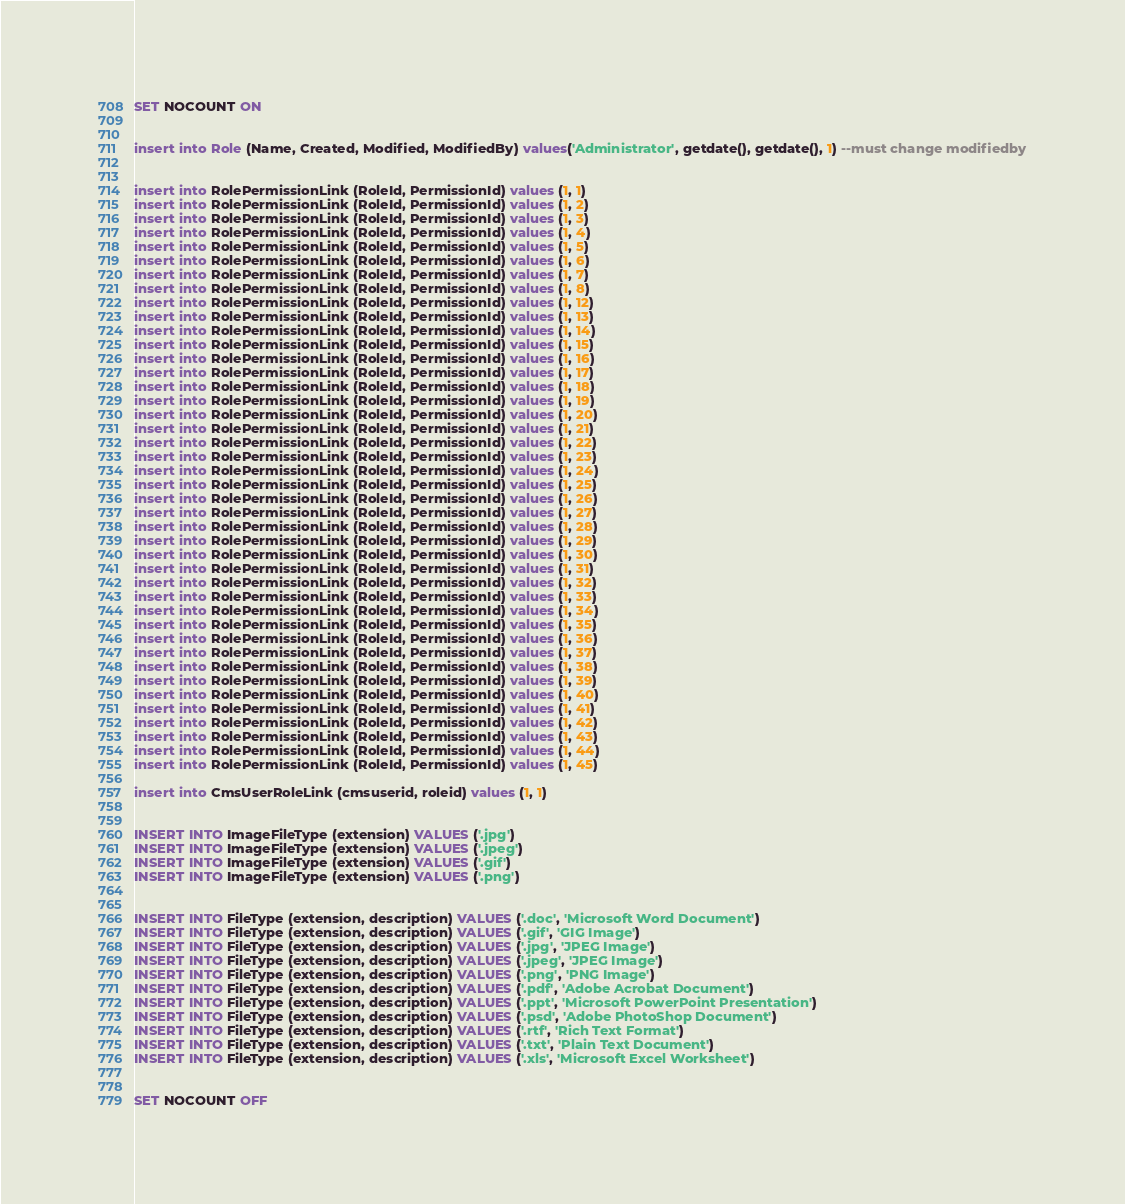<code> <loc_0><loc_0><loc_500><loc_500><_SQL_>SET NOCOUNT ON


insert into Role (Name, Created, Modified, ModifiedBy) values('Administrator', getdate(), getdate(), 1) --must change modifiedby


insert into RolePermissionLink (RoleId, PermissionId) values (1, 1)
insert into RolePermissionLink (RoleId, PermissionId) values (1, 2)
insert into RolePermissionLink (RoleId, PermissionId) values (1, 3)
insert into RolePermissionLink (RoleId, PermissionId) values (1, 4)
insert into RolePermissionLink (RoleId, PermissionId) values (1, 5)
insert into RolePermissionLink (RoleId, PermissionId) values (1, 6)
insert into RolePermissionLink (RoleId, PermissionId) values (1, 7)
insert into RolePermissionLink (RoleId, PermissionId) values (1, 8)
insert into RolePermissionLink (RoleId, PermissionId) values (1, 12)
insert into RolePermissionLink (RoleId, PermissionId) values (1, 13)
insert into RolePermissionLink (RoleId, PermissionId) values (1, 14)
insert into RolePermissionLink (RoleId, PermissionId) values (1, 15)
insert into RolePermissionLink (RoleId, PermissionId) values (1, 16)
insert into RolePermissionLink (RoleId, PermissionId) values (1, 17)
insert into RolePermissionLink (RoleId, PermissionId) values (1, 18)
insert into RolePermissionLink (RoleId, PermissionId) values (1, 19)
insert into RolePermissionLink (RoleId, PermissionId) values (1, 20)
insert into RolePermissionLink (RoleId, PermissionId) values (1, 21)
insert into RolePermissionLink (RoleId, PermissionId) values (1, 22)
insert into RolePermissionLink (RoleId, PermissionId) values (1, 23)
insert into RolePermissionLink (RoleId, PermissionId) values (1, 24)
insert into RolePermissionLink (RoleId, PermissionId) values (1, 25)
insert into RolePermissionLink (RoleId, PermissionId) values (1, 26)
insert into RolePermissionLink (RoleId, PermissionId) values (1, 27)
insert into RolePermissionLink (RoleId, PermissionId) values (1, 28)
insert into RolePermissionLink (RoleId, PermissionId) values (1, 29)
insert into RolePermissionLink (RoleId, PermissionId) values (1, 30)
insert into RolePermissionLink (RoleId, PermissionId) values (1, 31)
insert into RolePermissionLink (RoleId, PermissionId) values (1, 32)
insert into RolePermissionLink (RoleId, PermissionId) values (1, 33)
insert into RolePermissionLink (RoleId, PermissionId) values (1, 34)
insert into RolePermissionLink (RoleId, PermissionId) values (1, 35)
insert into RolePermissionLink (RoleId, PermissionId) values (1, 36)
insert into RolePermissionLink (RoleId, PermissionId) values (1, 37)
insert into RolePermissionLink (RoleId, PermissionId) values (1, 38)
insert into RolePermissionLink (RoleId, PermissionId) values (1, 39)
insert into RolePermissionLink (RoleId, PermissionId) values (1, 40)
insert into RolePermissionLink (RoleId, PermissionId) values (1, 41)
insert into RolePermissionLink (RoleId, PermissionId) values (1, 42)
insert into RolePermissionLink (RoleId, PermissionId) values (1, 43)
insert into RolePermissionLink (RoleId, PermissionId) values (1, 44)
insert into RolePermissionLink (RoleId, PermissionId) values (1, 45)

insert into CmsUserRoleLink (cmsuserid, roleid) values (1, 1)


INSERT INTO ImageFileType (extension) VALUES ('.jpg')
INSERT INTO ImageFileType (extension) VALUES ('.jpeg')
INSERT INTO ImageFileType (extension) VALUES ('.gif')
INSERT INTO ImageFileType (extension) VALUES ('.png')


INSERT INTO FileType (extension, description) VALUES ('.doc', 'Microsoft Word Document')
INSERT INTO FileType (extension, description) VALUES ('.gif', 'GIG Image')
INSERT INTO FileType (extension, description) VALUES ('.jpg', 'JPEG Image')
INSERT INTO FileType (extension, description) VALUES ('.jpeg', 'JPEG Image')
INSERT INTO FileType (extension, description) VALUES ('.png', 'PNG Image')
INSERT INTO FileType (extension, description) VALUES ('.pdf', 'Adobe Acrobat Document')
INSERT INTO FileType (extension, description) VALUES ('.ppt', 'Microsoft PowerPoint Presentation')
INSERT INTO FileType (extension, description) VALUES ('.psd', 'Adobe PhotoShop Document')
INSERT INTO FileType (extension, description) VALUES ('.rtf', 'Rich Text Format')
INSERT INTO FileType (extension, description) VALUES ('.txt', 'Plain Text Document')
INSERT INTO FileType (extension, description) VALUES ('.xls', 'Microsoft Excel Worksheet')


SET NOCOUNT OFF</code> 